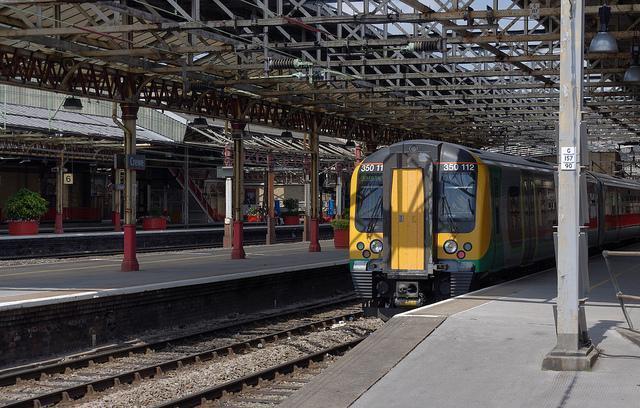Which numbers are fully visible on both the top left and top right of the front of the bus?
From the following set of four choices, select the accurate answer to respond to the question.
Options: 350, 399, 810, 220. 350. 